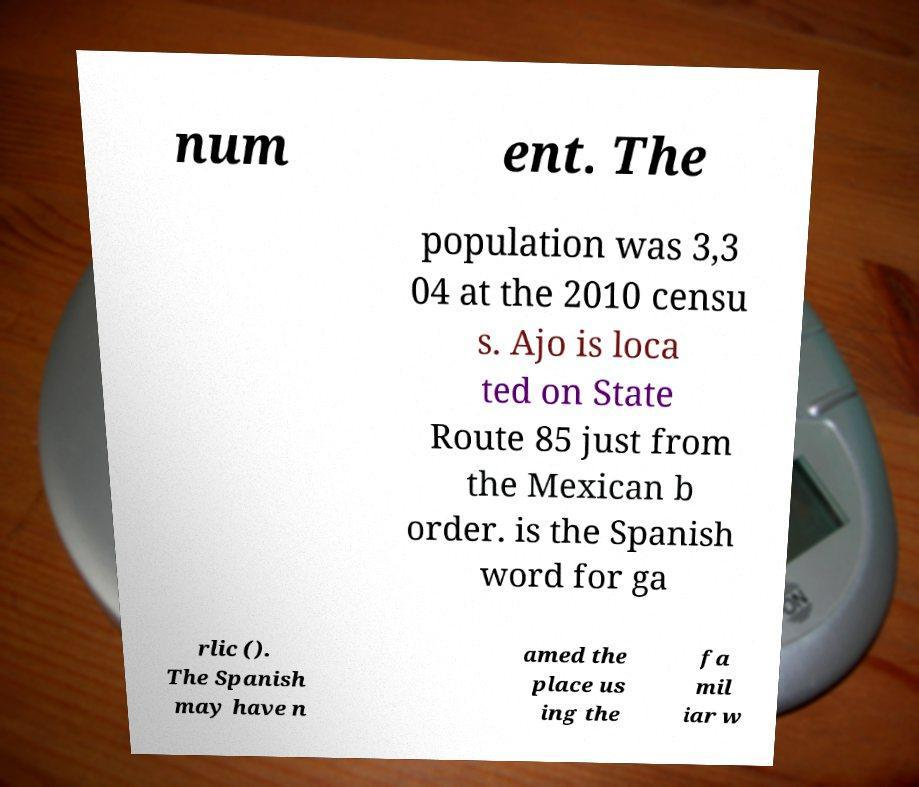Please identify and transcribe the text found in this image. num ent. The population was 3,3 04 at the 2010 censu s. Ajo is loca ted on State Route 85 just from the Mexican b order. is the Spanish word for ga rlic (). The Spanish may have n amed the place us ing the fa mil iar w 